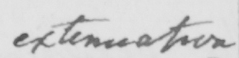What is written in this line of handwriting? extenuation 